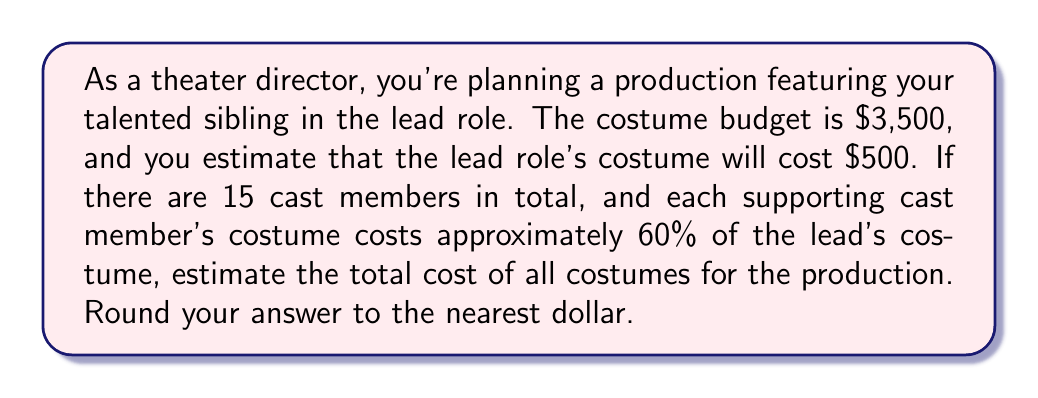Teach me how to tackle this problem. Let's break this problem down step-by-step:

1. Understand the given information:
   - Total budget: $3,500
   - Lead role costume cost: $500
   - Total cast members: 15
   - Supporting cast costume cost: 60% of lead's costume

2. Calculate the number of supporting cast members:
   $$\text{Supporting cast} = \text{Total cast} - \text{Lead role}$$
   $$\text{Supporting cast} = 15 - 1 = 14$$

3. Calculate the cost of one supporting cast member's costume:
   $$\text{Supporting costume cost} = 60\% \times \text{Lead costume cost}$$
   $$\text{Supporting costume cost} = 0.60 \times \$500 = \$300$$

4. Calculate the total cost for all supporting cast costumes:
   $$\text{Total supporting costumes} = \text{Supporting costume cost} \times \text{Number of supporting cast}$$
   $$\text{Total supporting costumes} = \$300 \times 14 = \$4,200$$

5. Calculate the total cost for all costumes:
   $$\text{Total cost} = \text{Lead costume cost} + \text{Total supporting costumes}$$
   $$\text{Total cost} = \$500 + \$4,200 = \$4,700$$

6. Round the answer to the nearest dollar:
   The result is already a whole number, so no rounding is necessary.
Answer: $4,700 